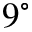Convert formula to latex. <formula><loc_0><loc_0><loc_500><loc_500>9 ^ { \circ }</formula> 